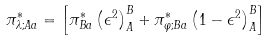Convert formula to latex. <formula><loc_0><loc_0><loc_500><loc_500>\pi _ { \lambda ; A a } ^ { * } = \left [ \pi _ { B a } ^ { * } \left ( \epsilon ^ { 2 } \right ) _ { A } ^ { B } + \pi _ { \varphi ; B a } ^ { * } \left ( 1 - \epsilon ^ { 2 } \right ) _ { A } ^ { B } \right ]</formula> 